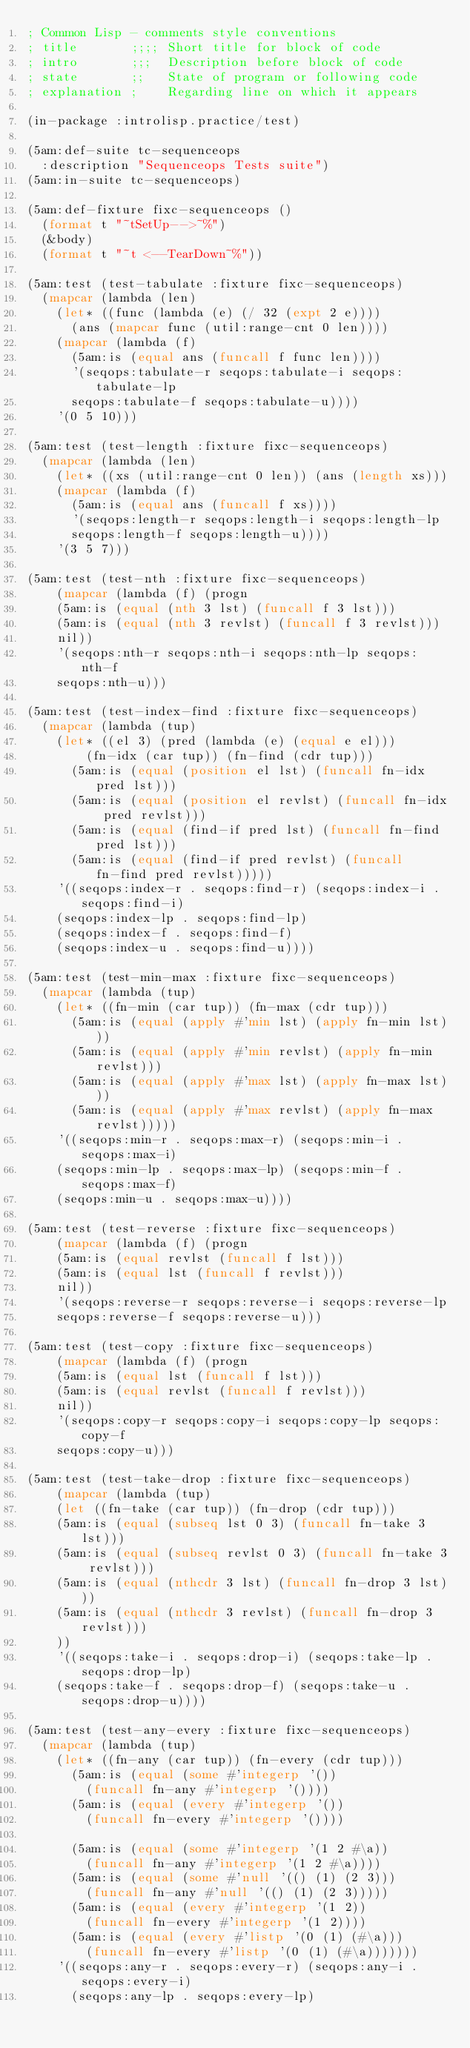<code> <loc_0><loc_0><loc_500><loc_500><_Lisp_>; Common Lisp - comments style conventions
; title       ;;;; Short title for block of code
; intro       ;;;  Description before block of code
; state       ;;   State of program or following code
; explanation ;    Regarding line on which it appears

(in-package :introlisp.practice/test)

(5am:def-suite tc-sequenceops
	:description "Sequenceops Tests suite")
(5am:in-suite tc-sequenceops)

(5am:def-fixture fixc-sequenceops ()
	(format t "~tSetUp-->~%")
	(&body)
	(format t "~t <--TearDown~%"))

(5am:test (test-tabulate :fixture fixc-sequenceops)
	(mapcar (lambda (len)
		(let* ((func (lambda (e) (/ 32 (expt 2 e))))
			(ans (mapcar func (util:range-cnt 0 len))))
		(mapcar (lambda (f)
			(5am:is (equal ans (funcall f func len))))
			'(seqops:tabulate-r seqops:tabulate-i seqops:tabulate-lp
			seqops:tabulate-f seqops:tabulate-u))))
		'(0 5 10)))

(5am:test (test-length :fixture fixc-sequenceops)
	(mapcar (lambda (len)
		(let* ((xs (util:range-cnt 0 len)) (ans (length xs)))
		(mapcar (lambda (f)
			(5am:is (equal ans (funcall f xs))))
			'(seqops:length-r seqops:length-i seqops:length-lp
			seqops:length-f seqops:length-u))))
		'(3 5 7)))

(5am:test (test-nth :fixture fixc-sequenceops)
    (mapcar (lambda (f) (progn
		(5am:is (equal (nth 3 lst) (funcall f 3 lst)))
		(5am:is (equal (nth 3 revlst) (funcall f 3 revlst)))
		nil))
		'(seqops:nth-r seqops:nth-i seqops:nth-lp seqops:nth-f
		seqops:nth-u)))

(5am:test (test-index-find :fixture fixc-sequenceops)
	(mapcar (lambda (tup)
		(let* ((el 3) (pred (lambda (e) (equal e el)))
				(fn-idx (car tup)) (fn-find (cdr tup)))
			(5am:is (equal (position el lst) (funcall fn-idx pred lst)))
			(5am:is (equal (position el revlst) (funcall fn-idx pred revlst)))
			(5am:is (equal (find-if pred lst) (funcall fn-find pred lst)))
			(5am:is (equal (find-if pred revlst) (funcall fn-find pred revlst)))))
		'((seqops:index-r . seqops:find-r) (seqops:index-i . seqops:find-i)
		(seqops:index-lp . seqops:find-lp)
		(seqops:index-f . seqops:find-f)
		(seqops:index-u . seqops:find-u))))

(5am:test (test-min-max :fixture fixc-sequenceops)
	(mapcar (lambda (tup)
		(let* ((fn-min (car tup)) (fn-max (cdr tup)))
			(5am:is (equal (apply #'min lst) (apply fn-min lst)))
			(5am:is (equal (apply #'min revlst) (apply fn-min revlst)))
			(5am:is (equal (apply #'max lst) (apply fn-max lst)))
			(5am:is (equal (apply #'max revlst) (apply fn-max revlst)))))
		'((seqops:min-r . seqops:max-r) (seqops:min-i . seqops:max-i) 
		(seqops:min-lp . seqops:max-lp) (seqops:min-f . seqops:max-f)
		(seqops:min-u . seqops:max-u))))

(5am:test (test-reverse :fixture fixc-sequenceops)
    (mapcar (lambda (f) (progn
		(5am:is (equal revlst (funcall f lst)))
		(5am:is (equal lst (funcall f revlst)))
		nil))
		'(seqops:reverse-r seqops:reverse-i seqops:reverse-lp
		seqops:reverse-f seqops:reverse-u)))

(5am:test (test-copy :fixture fixc-sequenceops)
    (mapcar (lambda (f) (progn
		(5am:is (equal lst (funcall f lst)))
		(5am:is (equal revlst (funcall f revlst)))
		nil))
		'(seqops:copy-r seqops:copy-i seqops:copy-lp seqops:copy-f
		seqops:copy-u)))

(5am:test (test-take-drop :fixture fixc-sequenceops)
    (mapcar (lambda (tup)
		(let ((fn-take (car tup)) (fn-drop (cdr tup)))
		(5am:is (equal (subseq lst 0 3) (funcall fn-take 3 lst)))
		(5am:is (equal (subseq revlst 0 3) (funcall fn-take 3 revlst)))
		(5am:is (equal (nthcdr 3 lst) (funcall fn-drop 3 lst)))
		(5am:is (equal (nthcdr 3 revlst) (funcall fn-drop 3 revlst)))
		))
		'((seqops:take-i . seqops:drop-i) (seqops:take-lp . seqops:drop-lp)
		(seqops:take-f . seqops:drop-f) (seqops:take-u . seqops:drop-u))))

(5am:test (test-any-every :fixture fixc-sequenceops)
	(mapcar (lambda (tup)
		(let* ((fn-any (car tup)) (fn-every (cdr tup)))
			(5am:is (equal (some #'integerp '()) 
				(funcall fn-any #'integerp '())))
			(5am:is (equal (every #'integerp '())
				(funcall fn-every #'integerp '())))
			
			(5am:is (equal (some #'integerp '(1 2 #\a)) 
				(funcall fn-any #'integerp '(1 2 #\a))))
			(5am:is (equal (some #'null '(() (1) (2 3))) 
				(funcall fn-any #'null '(() (1) (2 3)))))
			(5am:is (equal (every #'integerp '(1 2))
				(funcall fn-every #'integerp '(1 2))))
			(5am:is (equal (every #'listp '(0 (1) (#\a)))
				(funcall fn-every #'listp '(0 (1) (#\a)))))))
		'((seqops:any-r . seqops:every-r) (seqops:any-i . seqops:every-i)
			(seqops:any-lp . seqops:every-lp)</code> 